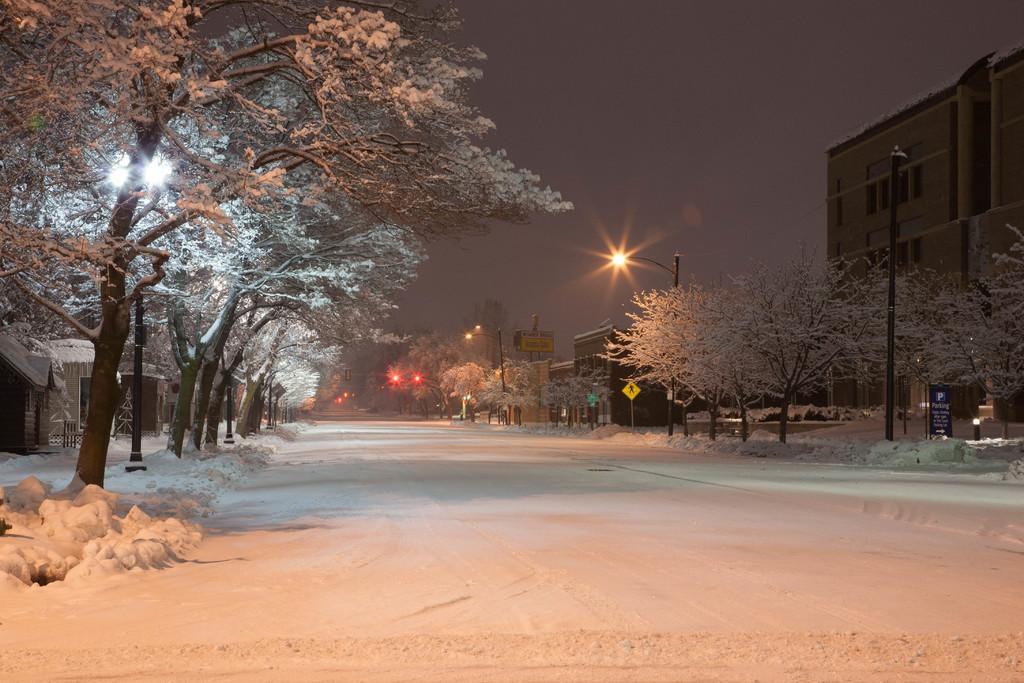How would you summarize this image in a sentence or two? In this image there is the sky towards the top of the image, there is a building towards the right of the image, there are buildings towards the left of the image, there are trees towards the right of the image, there are trees towards the left of the image, there are poles, there are streetlights, there are boards, there is text on the board, there is road towards the bottom of the image, there is snow on the road. 